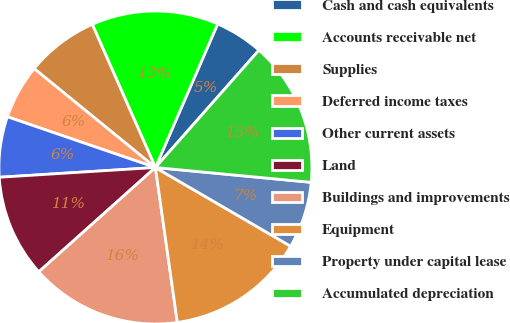Convert chart to OTSL. <chart><loc_0><loc_0><loc_500><loc_500><pie_chart><fcel>Cash and cash equivalents<fcel>Accounts receivable net<fcel>Supplies<fcel>Deferred income taxes<fcel>Other current assets<fcel>Land<fcel>Buildings and improvements<fcel>Equipment<fcel>Property under capital lease<fcel>Accumulated depreciation<nl><fcel>5.0%<fcel>13.12%<fcel>7.5%<fcel>5.63%<fcel>6.25%<fcel>10.62%<fcel>15.62%<fcel>14.37%<fcel>6.88%<fcel>15.0%<nl></chart> 